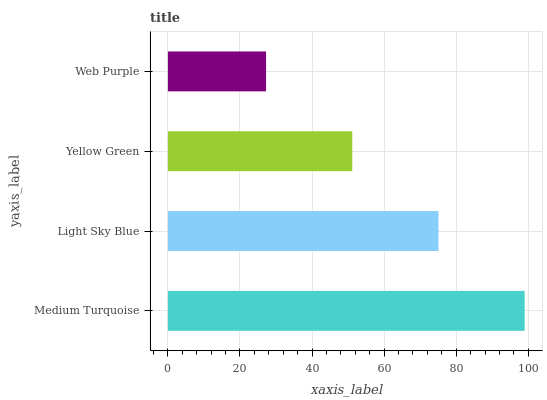Is Web Purple the minimum?
Answer yes or no. Yes. Is Medium Turquoise the maximum?
Answer yes or no. Yes. Is Light Sky Blue the minimum?
Answer yes or no. No. Is Light Sky Blue the maximum?
Answer yes or no. No. Is Medium Turquoise greater than Light Sky Blue?
Answer yes or no. Yes. Is Light Sky Blue less than Medium Turquoise?
Answer yes or no. Yes. Is Light Sky Blue greater than Medium Turquoise?
Answer yes or no. No. Is Medium Turquoise less than Light Sky Blue?
Answer yes or no. No. Is Light Sky Blue the high median?
Answer yes or no. Yes. Is Yellow Green the low median?
Answer yes or no. Yes. Is Web Purple the high median?
Answer yes or no. No. Is Light Sky Blue the low median?
Answer yes or no. No. 